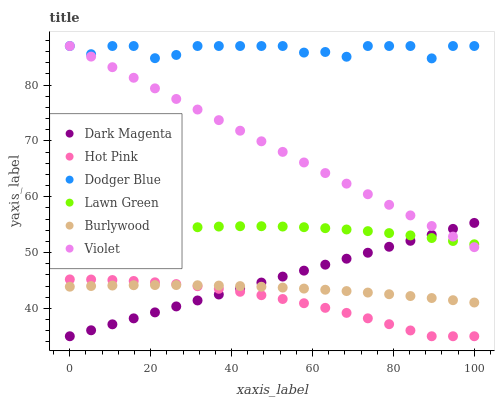Does Hot Pink have the minimum area under the curve?
Answer yes or no. Yes. Does Dodger Blue have the maximum area under the curve?
Answer yes or no. Yes. Does Dark Magenta have the minimum area under the curve?
Answer yes or no. No. Does Dark Magenta have the maximum area under the curve?
Answer yes or no. No. Is Dark Magenta the smoothest?
Answer yes or no. Yes. Is Dodger Blue the roughest?
Answer yes or no. Yes. Is Burlywood the smoothest?
Answer yes or no. No. Is Burlywood the roughest?
Answer yes or no. No. Does Dark Magenta have the lowest value?
Answer yes or no. Yes. Does Burlywood have the lowest value?
Answer yes or no. No. Does Violet have the highest value?
Answer yes or no. Yes. Does Dark Magenta have the highest value?
Answer yes or no. No. Is Hot Pink less than Violet?
Answer yes or no. Yes. Is Dodger Blue greater than Hot Pink?
Answer yes or no. Yes. Does Dark Magenta intersect Violet?
Answer yes or no. Yes. Is Dark Magenta less than Violet?
Answer yes or no. No. Is Dark Magenta greater than Violet?
Answer yes or no. No. Does Hot Pink intersect Violet?
Answer yes or no. No. 